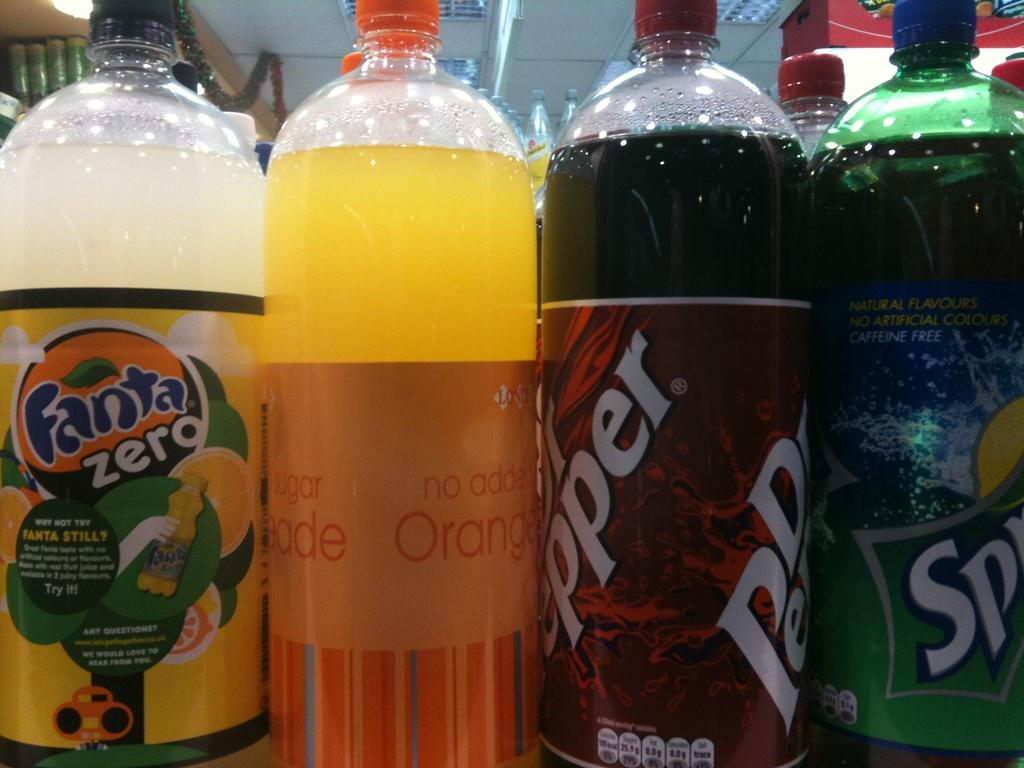<image>
Summarize the visual content of the image. Bottles of soda, including Fanta Zero, stand next to each other. 